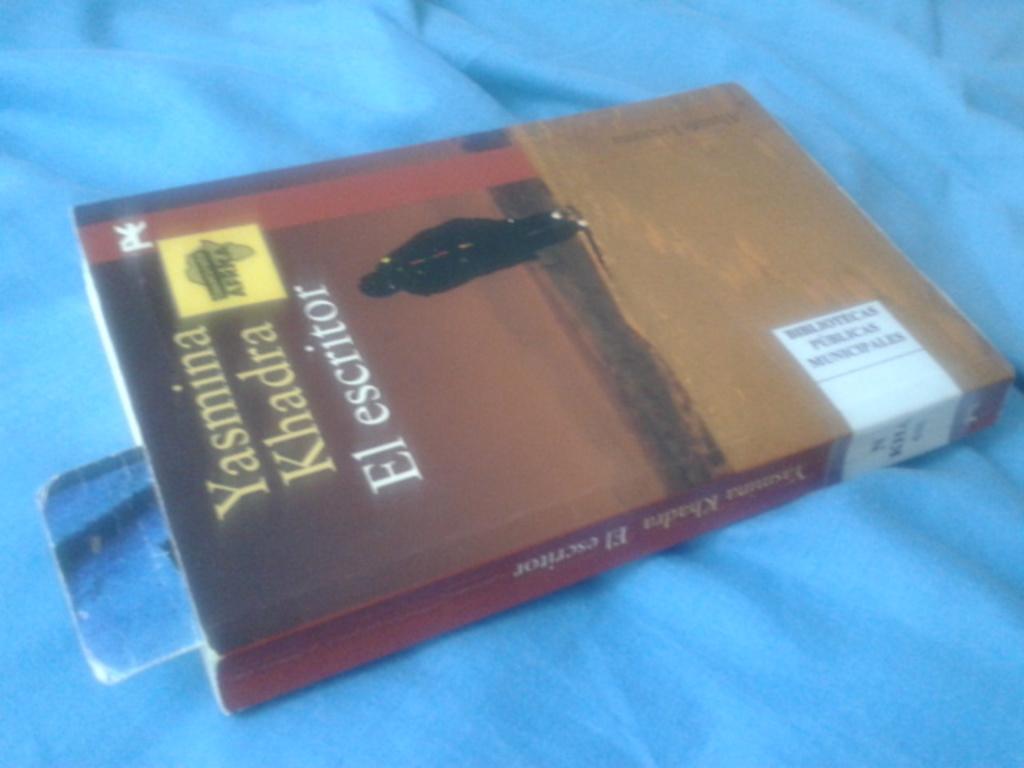The author of this book is?
Your answer should be very brief. Yasmina khadra. 